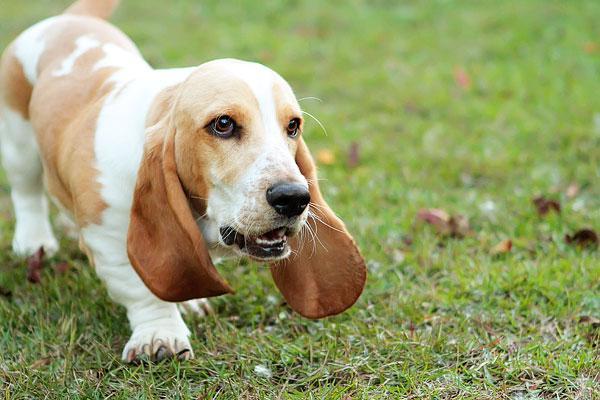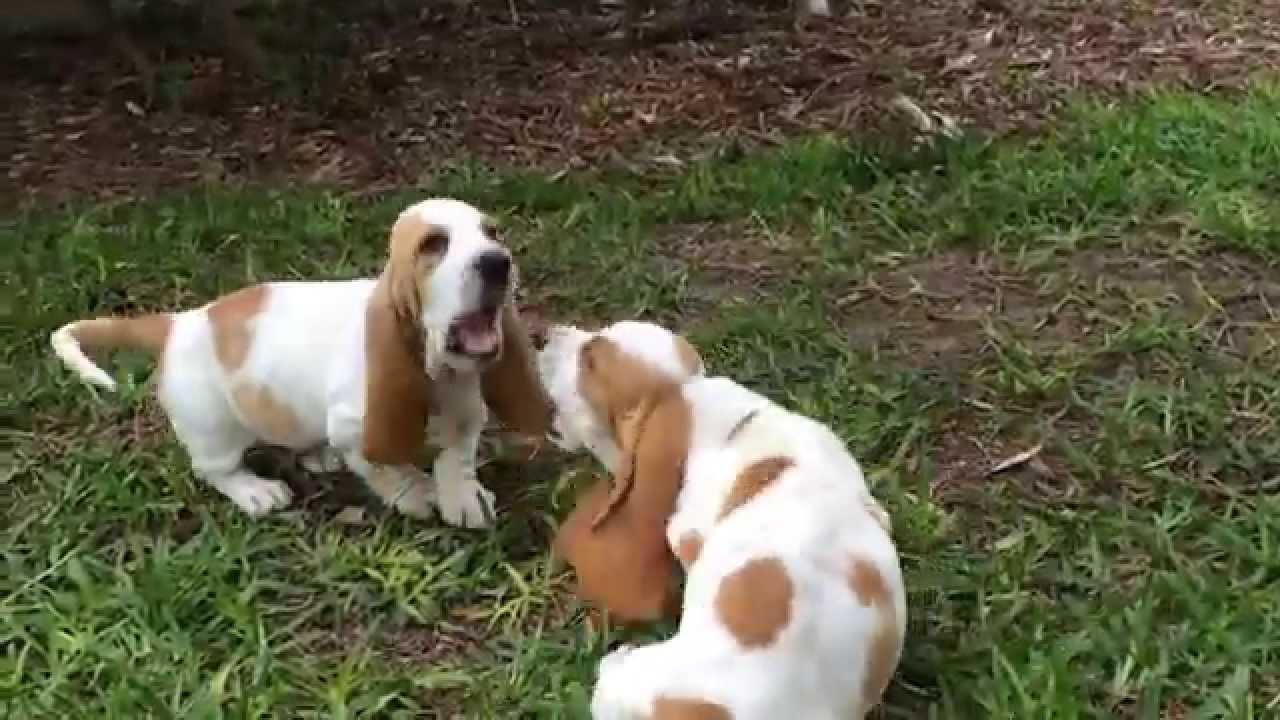The first image is the image on the left, the second image is the image on the right. Given the left and right images, does the statement "There is at least one pug and one baby." hold true? Answer yes or no. No. The first image is the image on the left, the second image is the image on the right. Evaluate the accuracy of this statement regarding the images: "In the right image, there's a single basset hound running through the grass.". Is it true? Answer yes or no. No. 